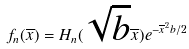Convert formula to latex. <formula><loc_0><loc_0><loc_500><loc_500>f _ { n } ( \overline { x } ) = H _ { n } ( \sqrt { b } \overline { x } ) e ^ { - \overline { x } ^ { 2 } b / 2 }</formula> 